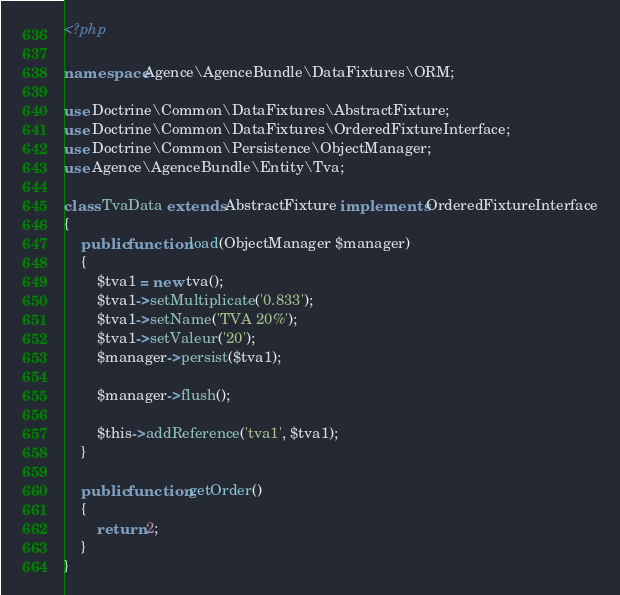Convert code to text. <code><loc_0><loc_0><loc_500><loc_500><_PHP_><?php

namespace Agence\AgenceBundle\DataFixtures\ORM;

use Doctrine\Common\DataFixtures\AbstractFixture;
use Doctrine\Common\DataFixtures\OrderedFixtureInterface;
use Doctrine\Common\Persistence\ObjectManager;
use Agence\AgenceBundle\Entity\Tva;

class TvaData extends AbstractFixture implements OrderedFixtureInterface
{
    public function load(ObjectManager $manager)
    {
        $tva1 = new tva();
        $tva1->setMultiplicate('0.833');
        $tva1->setName('TVA 20%');
        $tva1->setValeur('20');
        $manager->persist($tva1);

        $manager->flush();

        $this->addReference('tva1', $tva1);
    }

    public function getOrder()
    {
        return 2;
    }
}</code> 